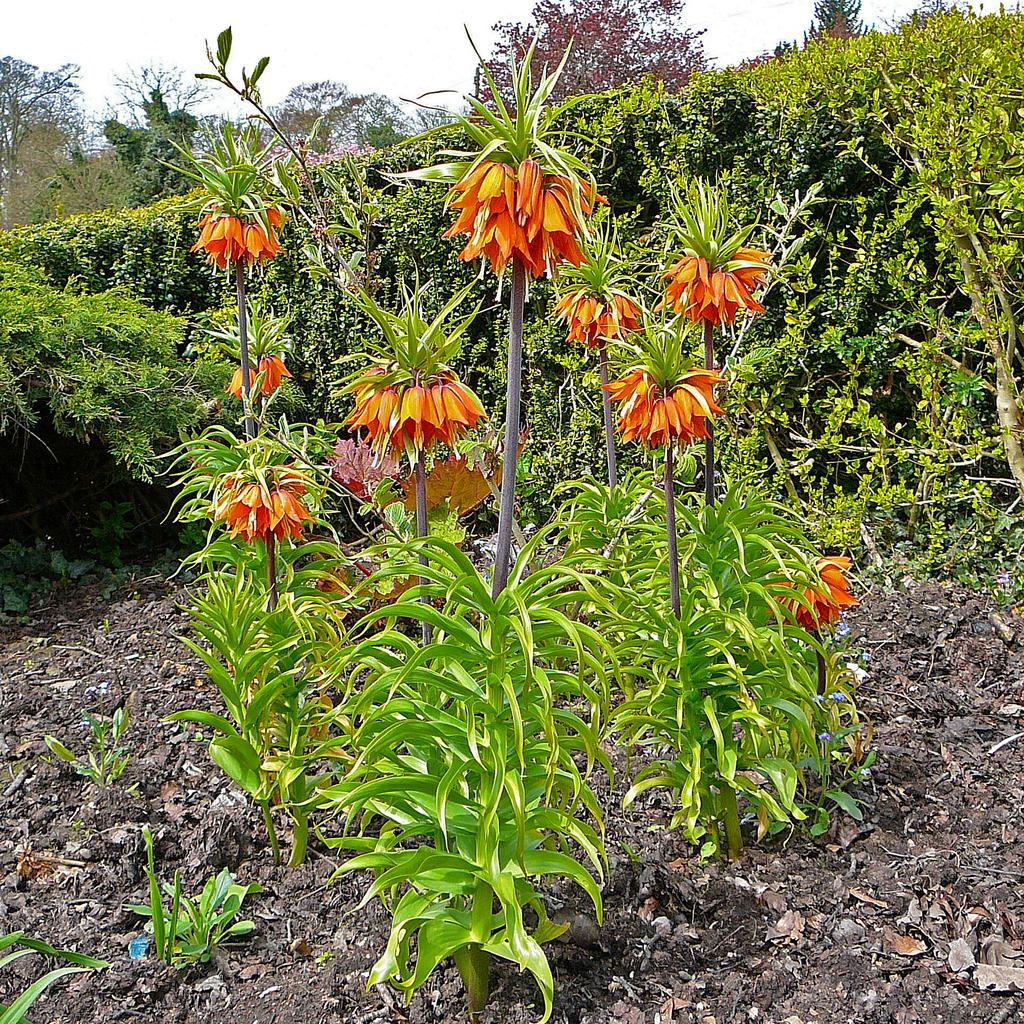What is located in the center of the image? There are plants in the center of the image. What type of plants can be seen in the image? There are flowers visible in the image. What can be seen in the background of the image? There are trees and bushes in the background of the image. What is visible at the top of the image? The sky is visible in the background of the image. What type of soda is being served under the umbrella in the image? There is no soda or umbrella present in the image; it features plants, flowers, trees, bushes, and the sky. 